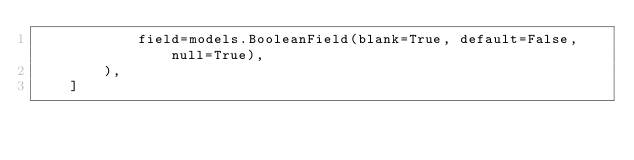Convert code to text. <code><loc_0><loc_0><loc_500><loc_500><_Python_>            field=models.BooleanField(blank=True, default=False, null=True),
        ),
    ]
</code> 